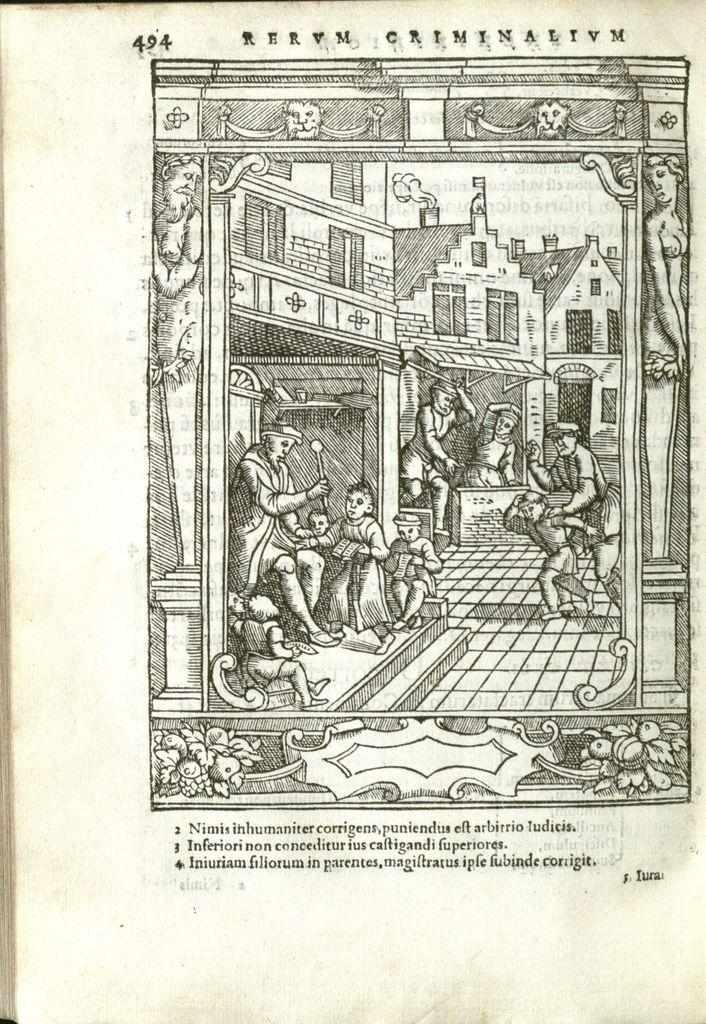What are the people in the image doing? There is a group of people on the floor in the image. What type of structures can be seen in the image? There are buildings in the image. What architectural features are present in the buildings? Doors are present in the image. What can be seen through the doors or windows? Windows are visible in the image. What is visible in the background of the image? The sky is visible in the image. Is there any text present in the image? Yes, text is present in the image. What is the format of the image? The image appears to be a paper cutting of a book. Can you tell me how many boots are visible in the image? There are no boots present in the image. What type of event is taking place in the image? The image does not depict an event; it is a paper cutting of a book. 